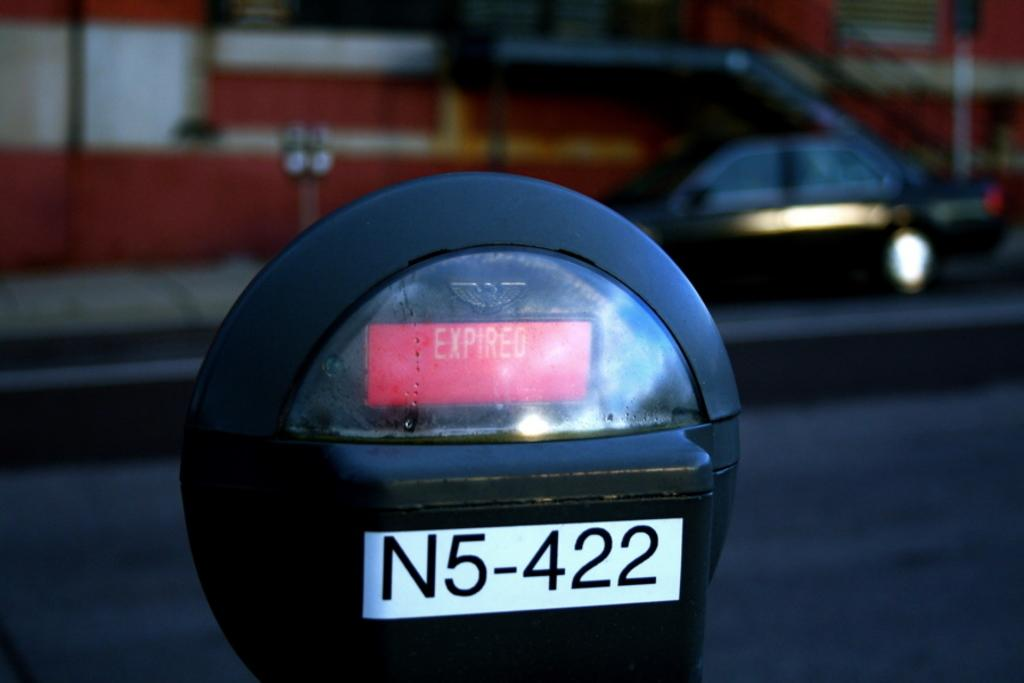<image>
Describe the image concisely. A digital readout says expired and above a N5-422 label. 